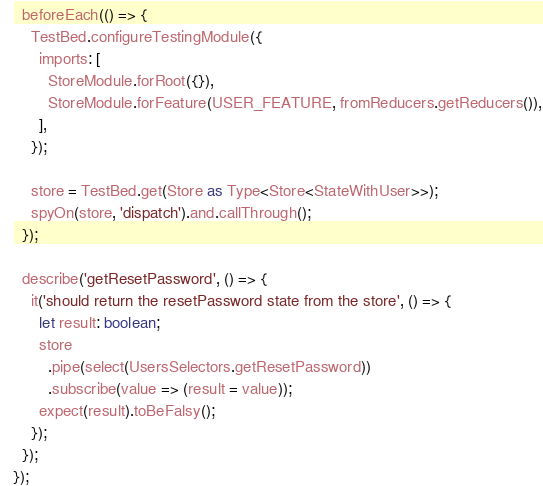<code> <loc_0><loc_0><loc_500><loc_500><_TypeScript_>  beforeEach(() => {
    TestBed.configureTestingModule({
      imports: [
        StoreModule.forRoot({}),
        StoreModule.forFeature(USER_FEATURE, fromReducers.getReducers()),
      ],
    });

    store = TestBed.get(Store as Type<Store<StateWithUser>>);
    spyOn(store, 'dispatch').and.callThrough();
  });

  describe('getResetPassword', () => {
    it('should return the resetPassword state from the store', () => {
      let result: boolean;
      store
        .pipe(select(UsersSelectors.getResetPassword))
        .subscribe(value => (result = value));
      expect(result).toBeFalsy();
    });
  });
});
</code> 